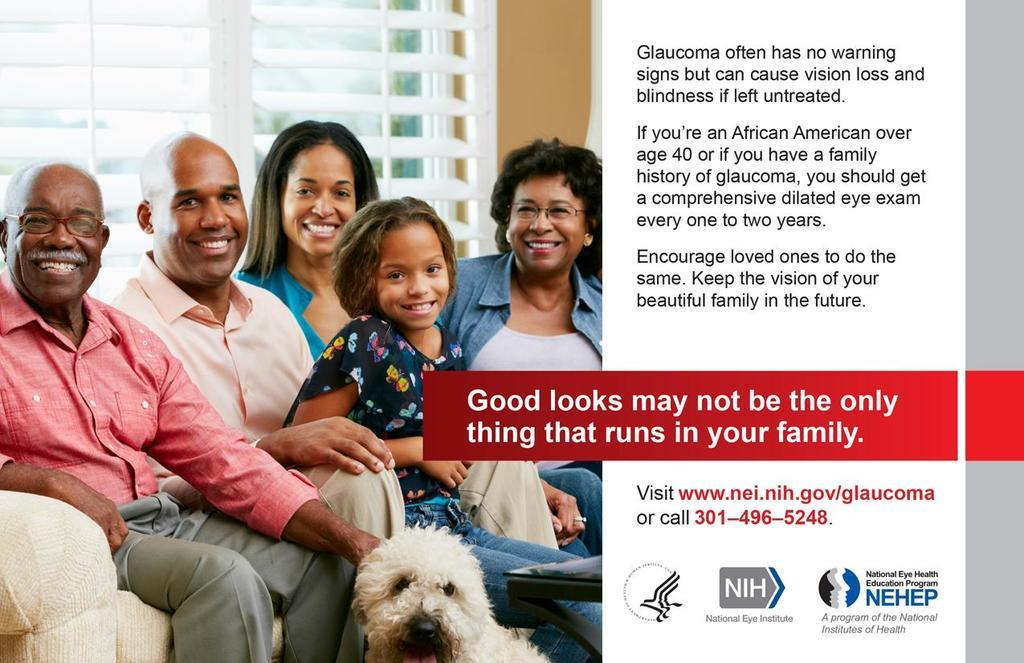What type of visual is the image? The image is a poster. What can be seen on the left side of the poster? There are people sitting on a sofa on the left side of the poster, and a dog at the person's leg. How is the text arranged on the right side of the poster? The text is written from the top to bottom on the right side of the poster. What type of board is the person on the left side of the poster using to read? There is no board present in the image, and the person is not reading. 